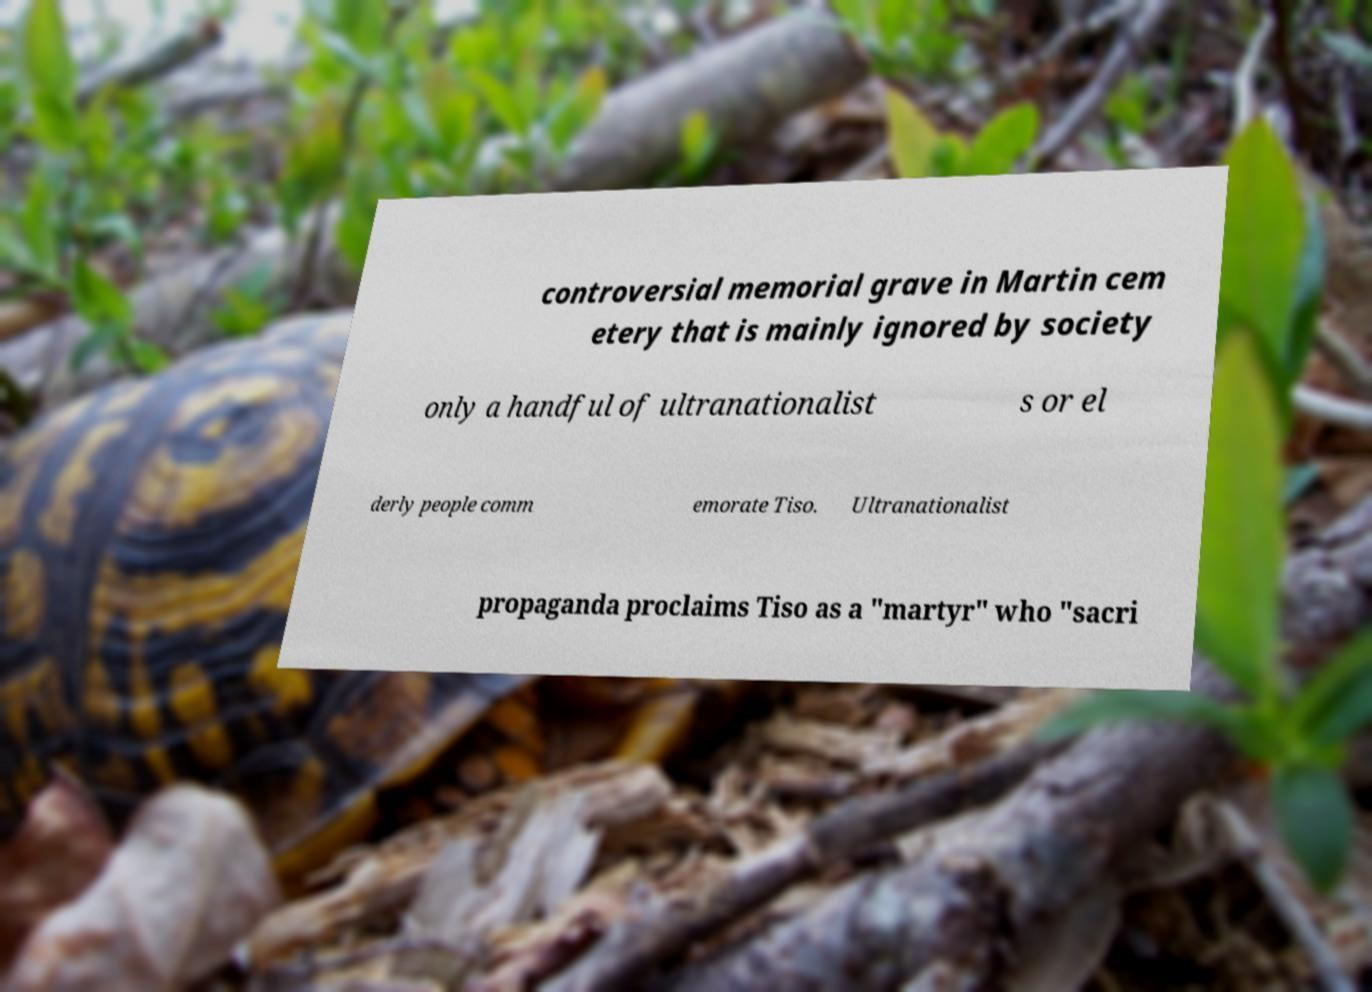Can you read and provide the text displayed in the image?This photo seems to have some interesting text. Can you extract and type it out for me? controversial memorial grave in Martin cem etery that is mainly ignored by society only a handful of ultranationalist s or el derly people comm emorate Tiso. Ultranationalist propaganda proclaims Tiso as a "martyr" who "sacri 